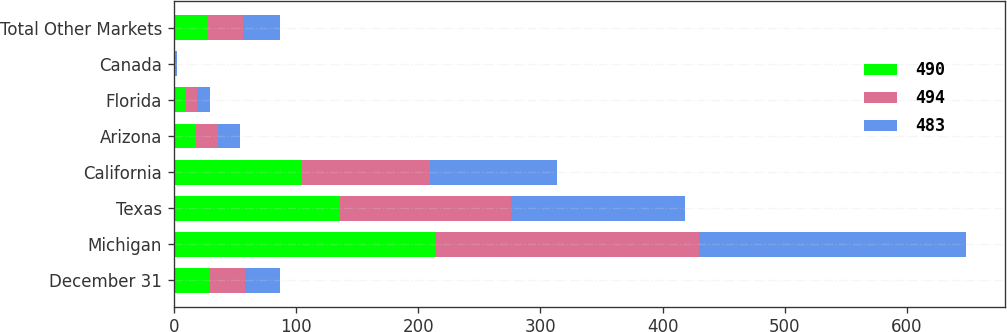Convert chart. <chart><loc_0><loc_0><loc_500><loc_500><stacked_bar_chart><ecel><fcel>December 31<fcel>Michigan<fcel>Texas<fcel>California<fcel>Arizona<fcel>Florida<fcel>Canada<fcel>Total Other Markets<nl><fcel>490<fcel>29<fcel>214<fcel>136<fcel>105<fcel>18<fcel>9<fcel>1<fcel>28<nl><fcel>494<fcel>29<fcel>216<fcel>140<fcel>105<fcel>18<fcel>10<fcel>1<fcel>29<nl><fcel>483<fcel>29<fcel>218<fcel>142<fcel>104<fcel>18<fcel>11<fcel>1<fcel>30<nl></chart> 